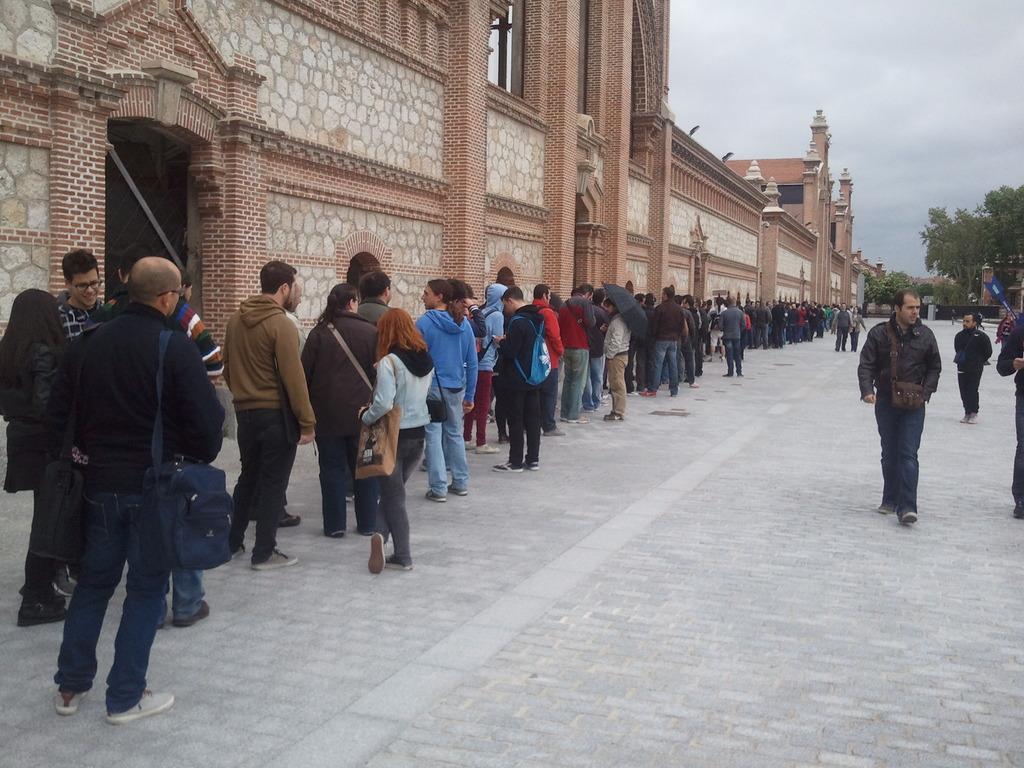How would you summarize this image in a sentence or two? In this image there is a building. In front of the building there are many people standing. To the right there are trees in the background. At the top there is the sky. 